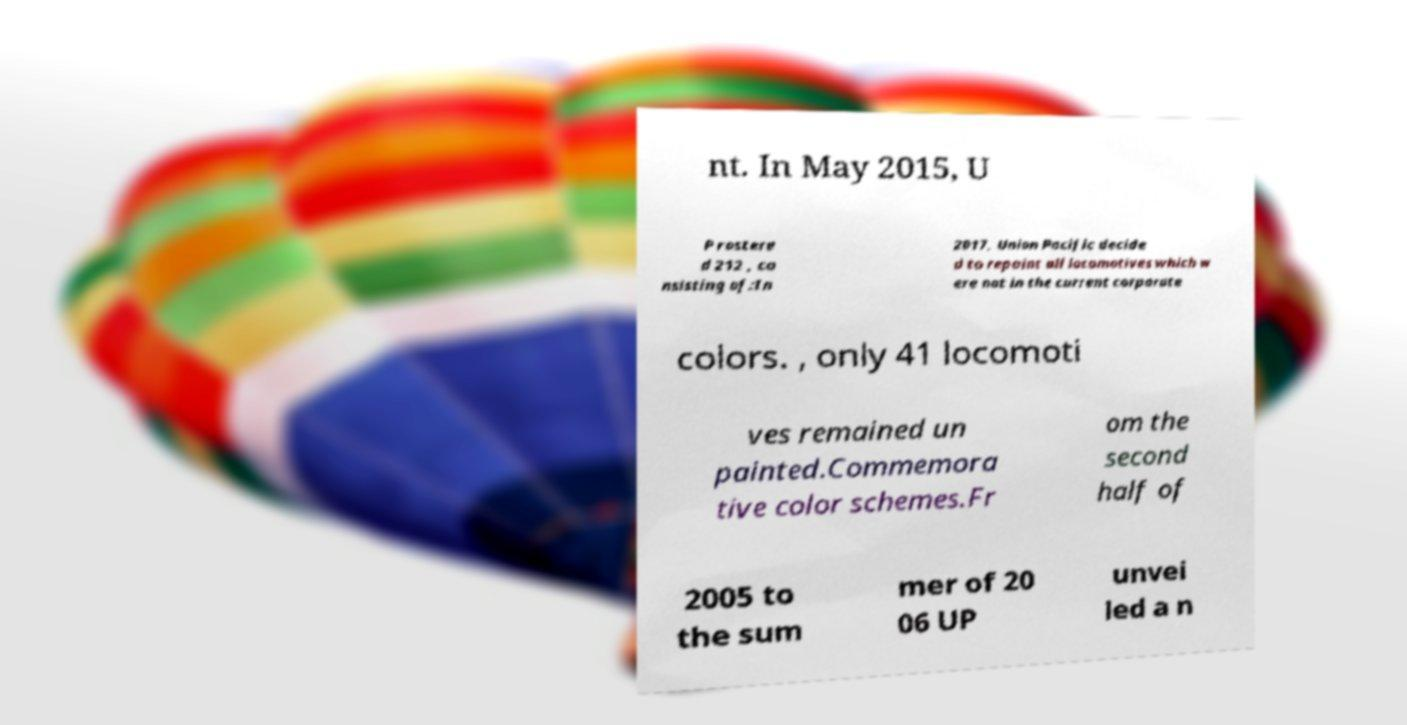Please read and relay the text visible in this image. What does it say? nt. In May 2015, U P rostere d 212 , co nsisting of:In 2017, Union Pacific decide d to repaint all locomotives which w ere not in the current corporate colors. , only 41 locomoti ves remained un painted.Commemora tive color schemes.Fr om the second half of 2005 to the sum mer of 20 06 UP unvei led a n 